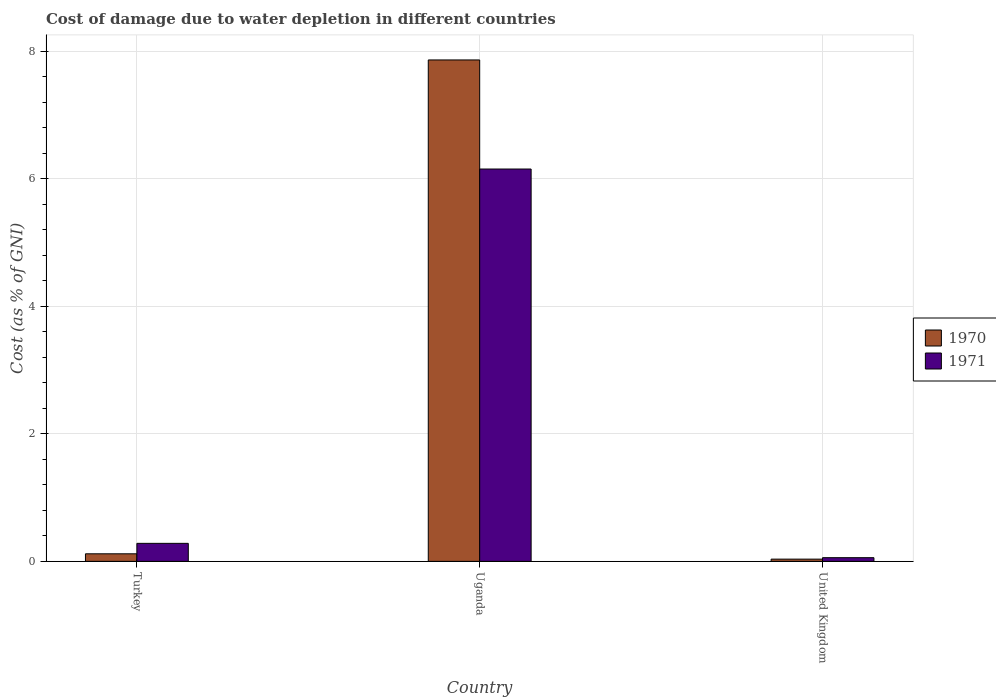How many different coloured bars are there?
Make the answer very short. 2. Are the number of bars on each tick of the X-axis equal?
Give a very brief answer. Yes. What is the label of the 2nd group of bars from the left?
Your answer should be very brief. Uganda. In how many cases, is the number of bars for a given country not equal to the number of legend labels?
Ensure brevity in your answer.  0. What is the cost of damage caused due to water depletion in 1970 in Turkey?
Offer a terse response. 0.12. Across all countries, what is the maximum cost of damage caused due to water depletion in 1971?
Offer a very short reply. 6.15. Across all countries, what is the minimum cost of damage caused due to water depletion in 1971?
Make the answer very short. 0.06. In which country was the cost of damage caused due to water depletion in 1970 maximum?
Provide a short and direct response. Uganda. In which country was the cost of damage caused due to water depletion in 1970 minimum?
Make the answer very short. United Kingdom. What is the total cost of damage caused due to water depletion in 1970 in the graph?
Your answer should be very brief. 8.02. What is the difference between the cost of damage caused due to water depletion in 1970 in Turkey and that in Uganda?
Keep it short and to the point. -7.74. What is the difference between the cost of damage caused due to water depletion in 1970 in Turkey and the cost of damage caused due to water depletion in 1971 in United Kingdom?
Provide a succinct answer. 0.06. What is the average cost of damage caused due to water depletion in 1970 per country?
Give a very brief answer. 2.67. What is the difference between the cost of damage caused due to water depletion of/in 1970 and cost of damage caused due to water depletion of/in 1971 in Turkey?
Offer a very short reply. -0.16. In how many countries, is the cost of damage caused due to water depletion in 1970 greater than 0.4 %?
Provide a short and direct response. 1. What is the ratio of the cost of damage caused due to water depletion in 1970 in Uganda to that in United Kingdom?
Offer a very short reply. 224.06. Is the cost of damage caused due to water depletion in 1971 in Turkey less than that in Uganda?
Your response must be concise. Yes. What is the difference between the highest and the second highest cost of damage caused due to water depletion in 1971?
Keep it short and to the point. -5.87. What is the difference between the highest and the lowest cost of damage caused due to water depletion in 1970?
Offer a very short reply. 7.83. What does the 2nd bar from the left in Turkey represents?
Offer a very short reply. 1971. How many bars are there?
Make the answer very short. 6. Are the values on the major ticks of Y-axis written in scientific E-notation?
Offer a very short reply. No. What is the title of the graph?
Your response must be concise. Cost of damage due to water depletion in different countries. Does "1971" appear as one of the legend labels in the graph?
Your answer should be very brief. Yes. What is the label or title of the X-axis?
Your answer should be compact. Country. What is the label or title of the Y-axis?
Make the answer very short. Cost (as % of GNI). What is the Cost (as % of GNI) in 1970 in Turkey?
Give a very brief answer. 0.12. What is the Cost (as % of GNI) in 1971 in Turkey?
Keep it short and to the point. 0.28. What is the Cost (as % of GNI) of 1970 in Uganda?
Ensure brevity in your answer.  7.86. What is the Cost (as % of GNI) in 1971 in Uganda?
Offer a very short reply. 6.15. What is the Cost (as % of GNI) of 1970 in United Kingdom?
Offer a terse response. 0.04. What is the Cost (as % of GNI) in 1971 in United Kingdom?
Offer a very short reply. 0.06. Across all countries, what is the maximum Cost (as % of GNI) in 1970?
Offer a very short reply. 7.86. Across all countries, what is the maximum Cost (as % of GNI) of 1971?
Provide a succinct answer. 6.15. Across all countries, what is the minimum Cost (as % of GNI) of 1970?
Keep it short and to the point. 0.04. Across all countries, what is the minimum Cost (as % of GNI) in 1971?
Provide a short and direct response. 0.06. What is the total Cost (as % of GNI) of 1970 in the graph?
Your answer should be very brief. 8.02. What is the total Cost (as % of GNI) in 1971 in the graph?
Provide a short and direct response. 6.49. What is the difference between the Cost (as % of GNI) of 1970 in Turkey and that in Uganda?
Provide a short and direct response. -7.74. What is the difference between the Cost (as % of GNI) of 1971 in Turkey and that in Uganda?
Give a very brief answer. -5.87. What is the difference between the Cost (as % of GNI) of 1970 in Turkey and that in United Kingdom?
Make the answer very short. 0.08. What is the difference between the Cost (as % of GNI) in 1971 in Turkey and that in United Kingdom?
Ensure brevity in your answer.  0.22. What is the difference between the Cost (as % of GNI) in 1970 in Uganda and that in United Kingdom?
Give a very brief answer. 7.83. What is the difference between the Cost (as % of GNI) of 1971 in Uganda and that in United Kingdom?
Provide a short and direct response. 6.09. What is the difference between the Cost (as % of GNI) in 1970 in Turkey and the Cost (as % of GNI) in 1971 in Uganda?
Keep it short and to the point. -6.03. What is the difference between the Cost (as % of GNI) of 1970 in Turkey and the Cost (as % of GNI) of 1971 in United Kingdom?
Ensure brevity in your answer.  0.06. What is the difference between the Cost (as % of GNI) in 1970 in Uganda and the Cost (as % of GNI) in 1971 in United Kingdom?
Ensure brevity in your answer.  7.8. What is the average Cost (as % of GNI) of 1970 per country?
Offer a very short reply. 2.67. What is the average Cost (as % of GNI) in 1971 per country?
Keep it short and to the point. 2.16. What is the difference between the Cost (as % of GNI) of 1970 and Cost (as % of GNI) of 1971 in Turkey?
Provide a succinct answer. -0.16. What is the difference between the Cost (as % of GNI) in 1970 and Cost (as % of GNI) in 1971 in Uganda?
Your answer should be compact. 1.71. What is the difference between the Cost (as % of GNI) in 1970 and Cost (as % of GNI) in 1971 in United Kingdom?
Your answer should be very brief. -0.02. What is the ratio of the Cost (as % of GNI) in 1970 in Turkey to that in Uganda?
Your response must be concise. 0.02. What is the ratio of the Cost (as % of GNI) in 1971 in Turkey to that in Uganda?
Keep it short and to the point. 0.05. What is the ratio of the Cost (as % of GNI) of 1970 in Turkey to that in United Kingdom?
Your answer should be compact. 3.38. What is the ratio of the Cost (as % of GNI) of 1971 in Turkey to that in United Kingdom?
Give a very brief answer. 4.9. What is the ratio of the Cost (as % of GNI) of 1970 in Uganda to that in United Kingdom?
Provide a short and direct response. 224.06. What is the ratio of the Cost (as % of GNI) of 1971 in Uganda to that in United Kingdom?
Your answer should be very brief. 106.62. What is the difference between the highest and the second highest Cost (as % of GNI) of 1970?
Offer a terse response. 7.74. What is the difference between the highest and the second highest Cost (as % of GNI) of 1971?
Give a very brief answer. 5.87. What is the difference between the highest and the lowest Cost (as % of GNI) in 1970?
Provide a succinct answer. 7.83. What is the difference between the highest and the lowest Cost (as % of GNI) of 1971?
Provide a succinct answer. 6.09. 